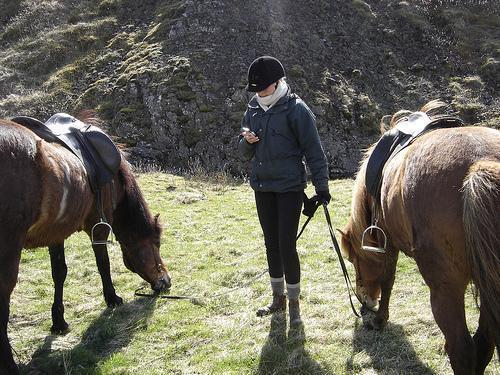How many horses are there?
Give a very brief answer. 2. How many horses are eating grass?
Give a very brief answer. 2. 